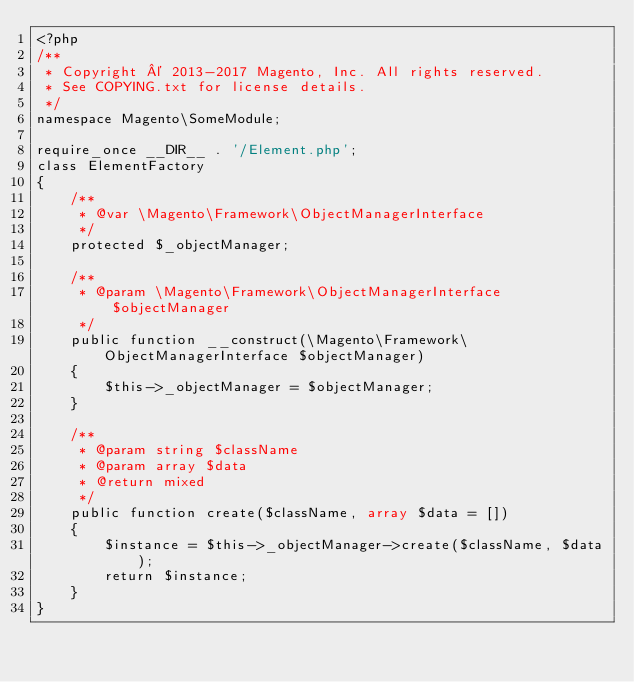Convert code to text. <code><loc_0><loc_0><loc_500><loc_500><_PHP_><?php
/**
 * Copyright © 2013-2017 Magento, Inc. All rights reserved.
 * See COPYING.txt for license details.
 */
namespace Magento\SomeModule;

require_once __DIR__ . '/Element.php';
class ElementFactory
{
    /**
     * @var \Magento\Framework\ObjectManagerInterface
     */
    protected $_objectManager;

    /**
     * @param \Magento\Framework\ObjectManagerInterface $objectManager
     */
    public function __construct(\Magento\Framework\ObjectManagerInterface $objectManager)
    {
        $this->_objectManager = $objectManager;
    }

    /**
     * @param string $className
     * @param array $data
     * @return mixed
     */
    public function create($className, array $data = [])
    {
        $instance = $this->_objectManager->create($className, $data);
        return $instance;
    }
}
</code> 